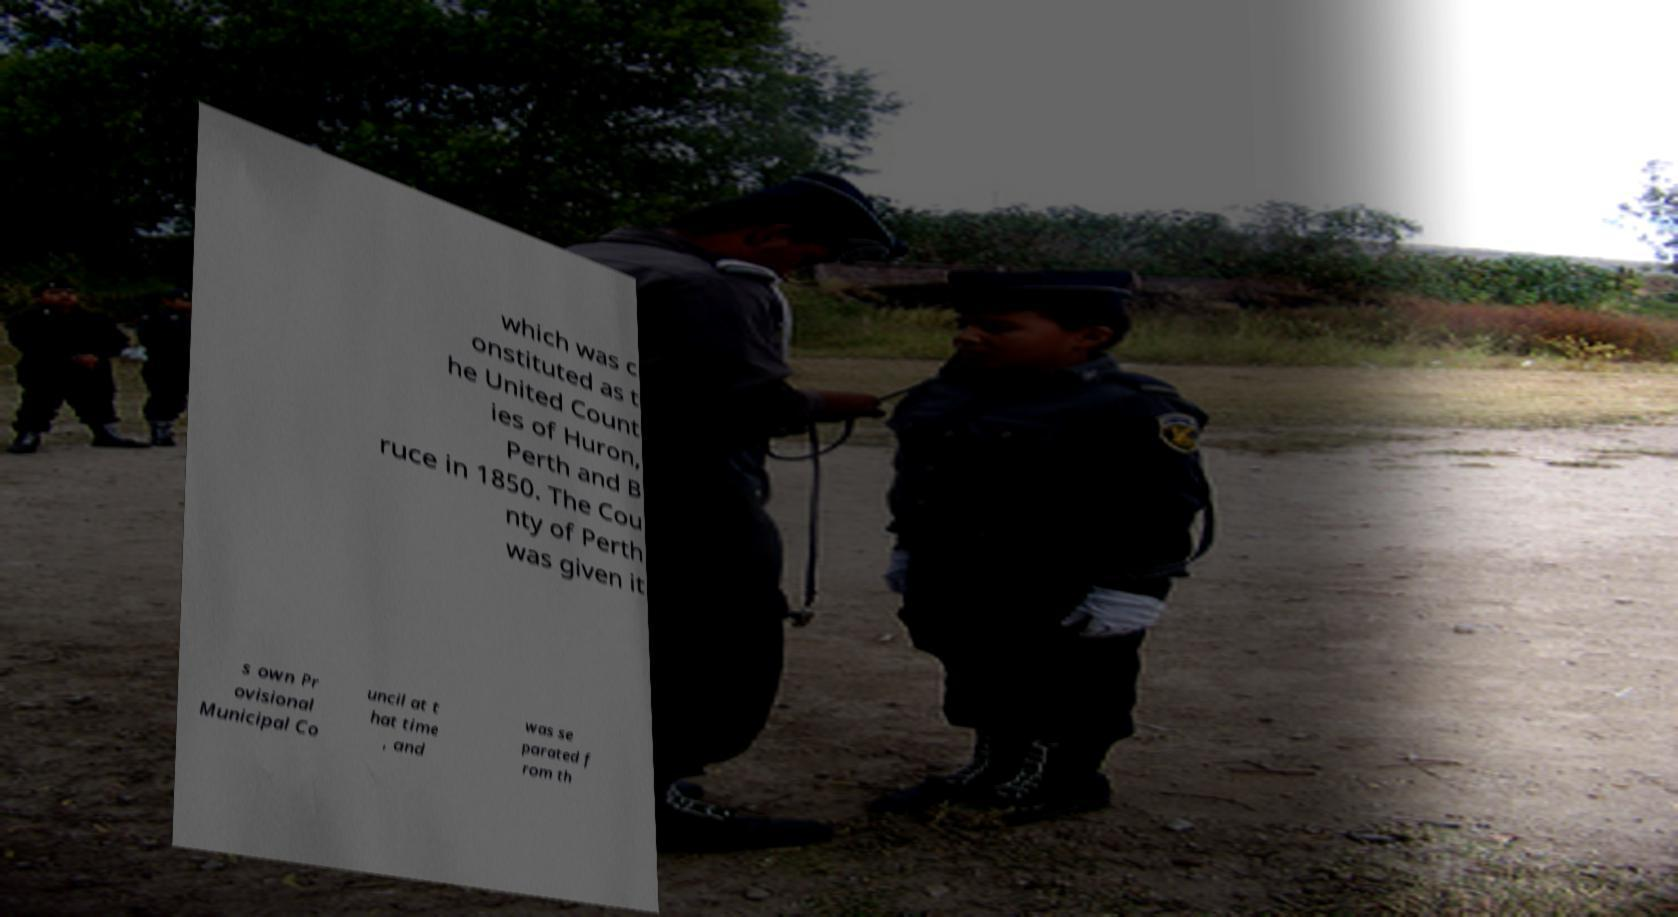I need the written content from this picture converted into text. Can you do that? which was c onstituted as t he United Count ies of Huron, Perth and B ruce in 1850. The Cou nty of Perth was given it s own Pr ovisional Municipal Co uncil at t hat time , and was se parated f rom th 